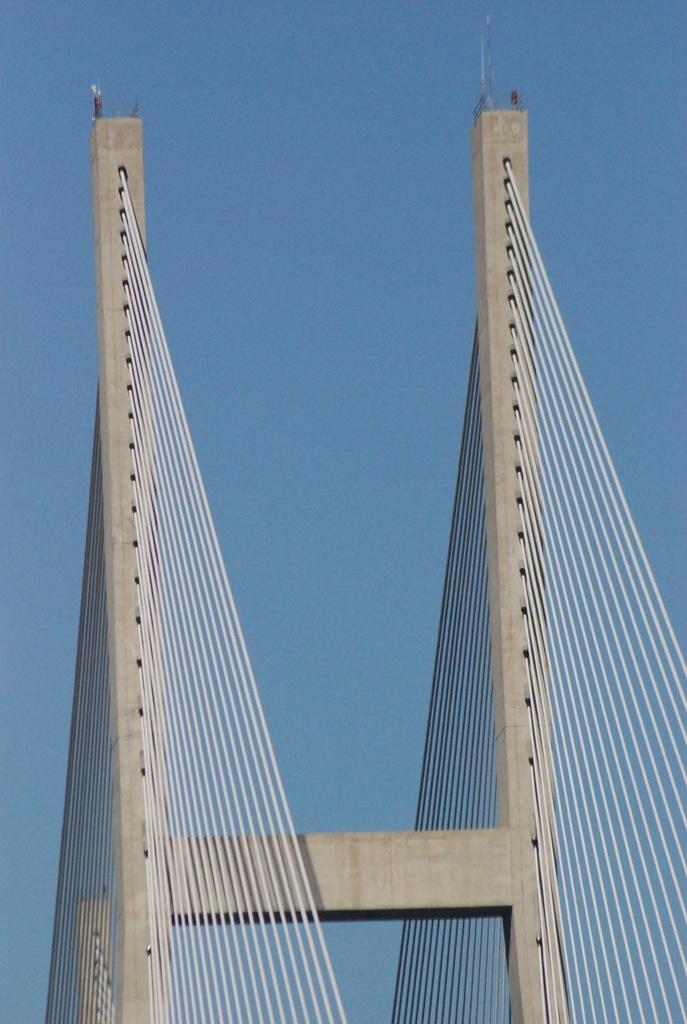Could you give a brief overview of what you see in this image? In this image, we can see a cable stayed bridge and we can see the sky. 